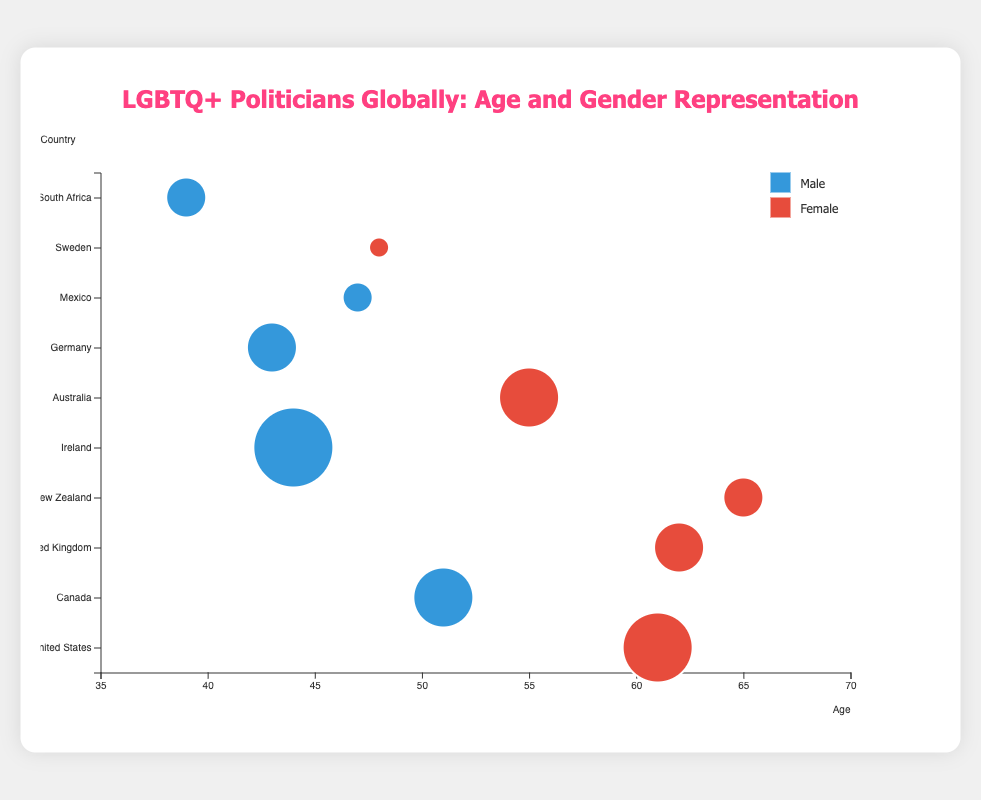Which country has the youngest LGBTQ+ politician depicted in the figure? The y-axis shows different countries, and the x-axis shows the age of each politician. By finding the data point furthest to the left, which represents the youngest age, we can identify the country.
Answer: South Africa What is the average age of female LGBTQ+ politicians in the figure? First, identify the ages of all female politicians: 61, 62, 65, 55, 48. Then calculate the average: (61 + 62 + 65 + 55 + 48) / 5 = 291 / 5 = 58.2.
Answer: 58.2 Which politician has the highest importance score? Importance is depicted by the size of the bubbles. The largest bubble represents the politician with the highest importance. By examining the figure, identify the largest bubble and note the corresponding politician's name.
Answer: Leo Varadkar How many male LGBTQ+ politicians are represented in the figure? The color of the bubbles represents gender: males are blue. Count the number of blue bubbles in the chart.
Answer: 5 Which country’s politician is oldest? The x-axis represents age, so find the data point furthest to the right. Then, look at the y-axis to identify the corresponding country.
Answer: New Zealand Compare the importance scores between the youngest and oldest politicians. Who has a higher score, and by how much? The youngest politician is from South Africa (39 years, 75 importance), and the oldest is from New Zealand (65 years, 75 importance). Their importance scores are equal.
Answer: Both are equal What is the gender distribution among LGBTQ+ politicians from English-speaking countries in the chart? English-speaking countries listed are the United States, Canada, United Kingdom, New Zealand, Ireland, and Australia. Identify these countries in the y-axis and note the color of their bubbles. U.S. (Female), Canada (Male), U.K. (Female), New Zealand (Female), Ireland (Male), Australia (Female). This gives us 4 females and 2 males.
Answer: 4 females and 2 males Which female politician has the highest importance score? Identify the red bubbles (females) and find the largest one. Then, note the corresponding politician’s name.
Answer: Tammy Baldwin How does the average age of male politicians compare to the average age of female politicians? Calculate the average age of male politicians: 51 + 44 + 43 + 47 + 39 = 224/5 = 44.8. Compare this to the previously calculated average age for females (58.2). Finally, determine which is higher.
Answer: Females are older, 58.2 vs 44.8 What is the most common age range for LGBTQ+ politicians in the given dataset? The x-axis represents age, so visually observe the clustering of bubbles along the x-axis. Most bubbles are situated between ages 40 and 60.
Answer: 40-60 years 